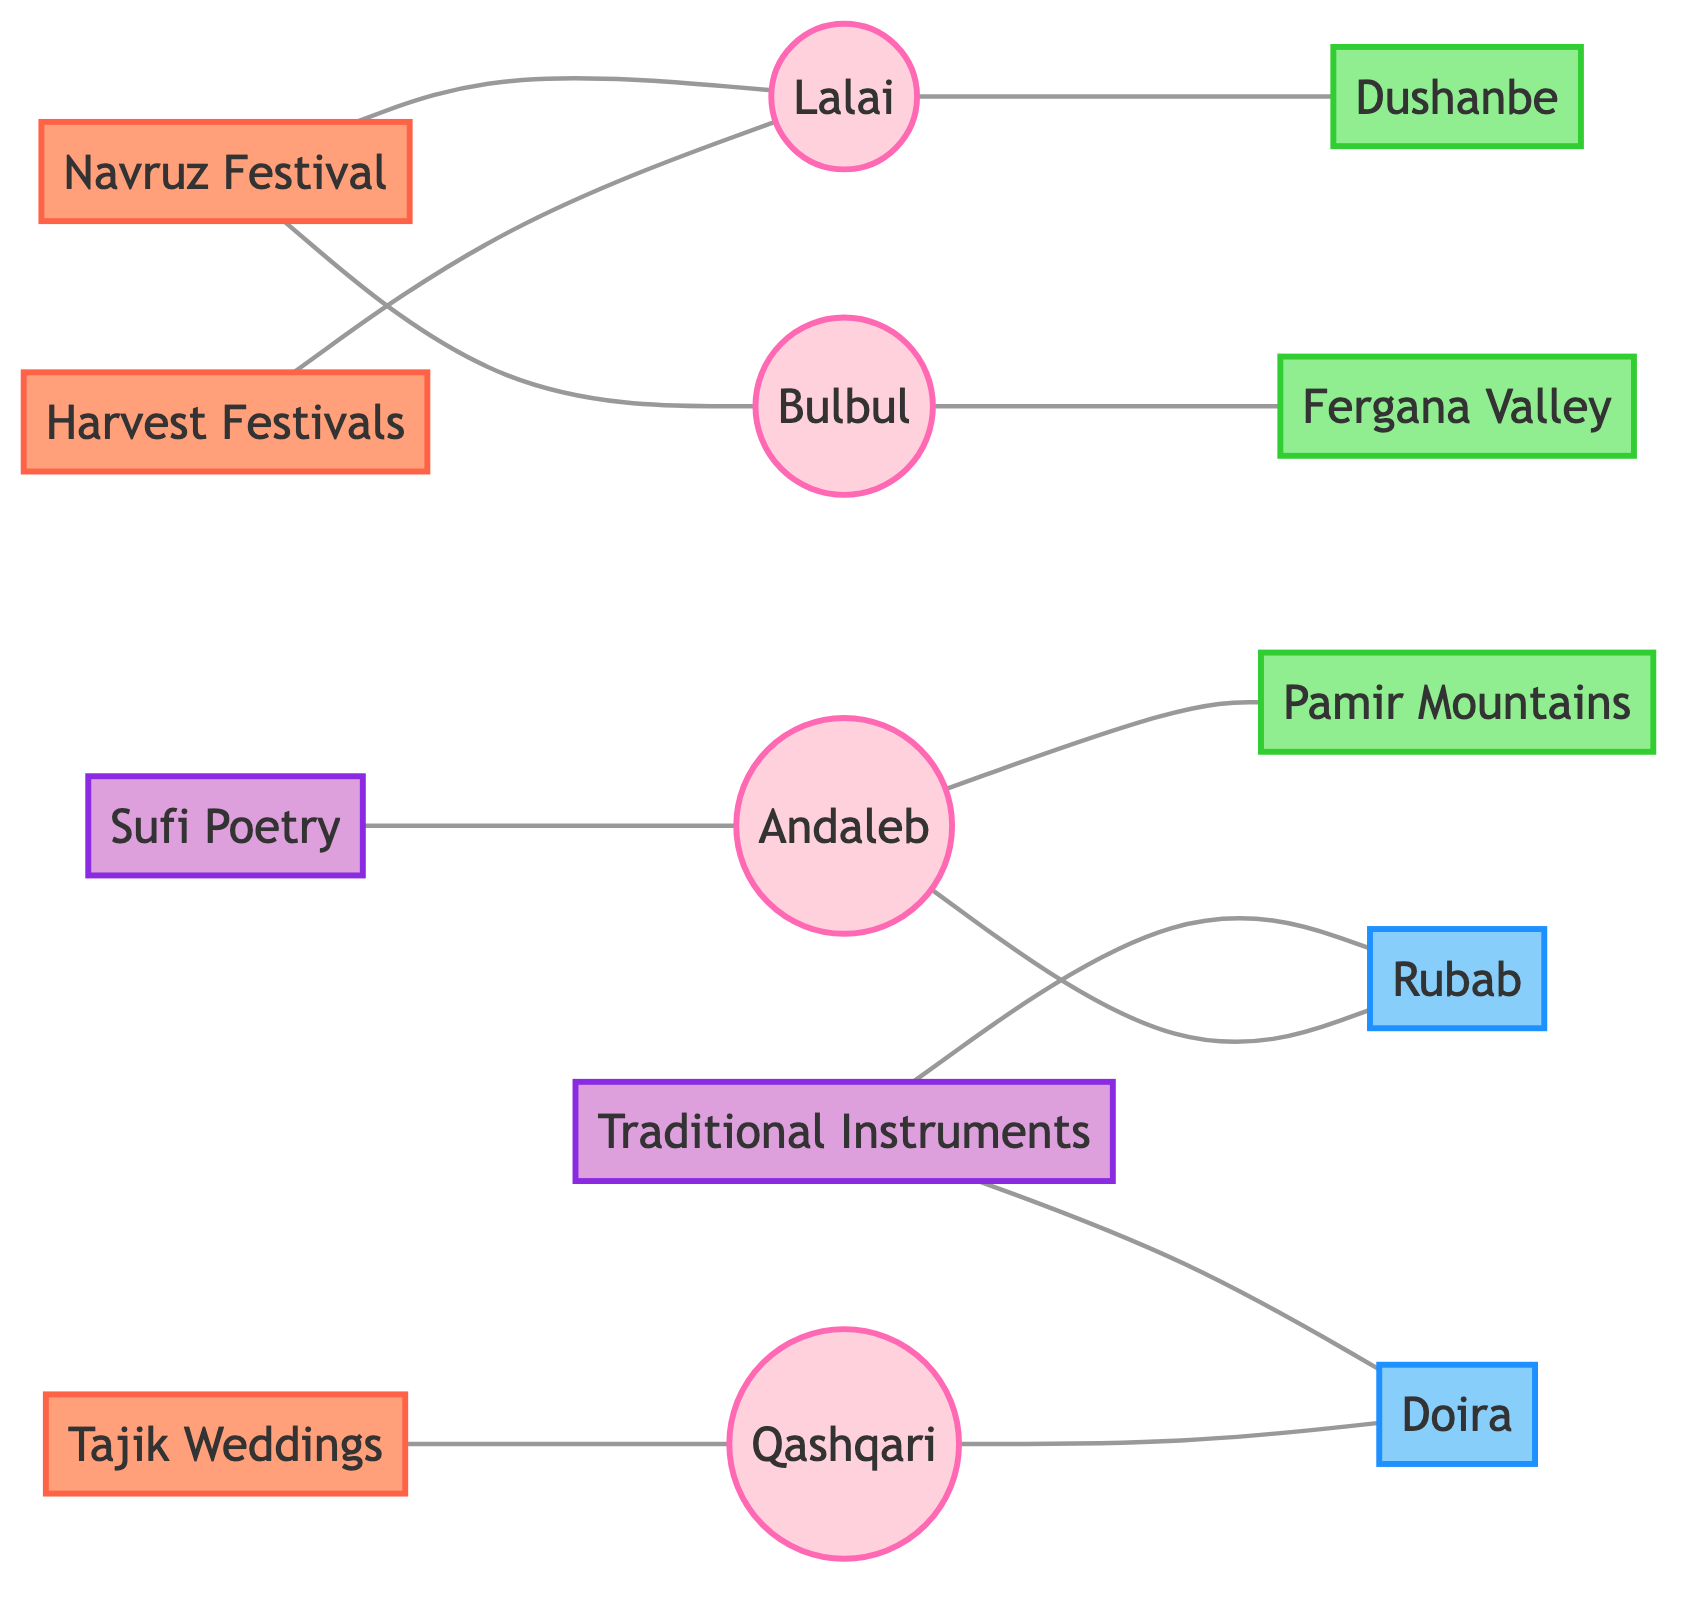What is the origin of the Andaleb folk song? The diagram shows a direct connection labeled "origin" between the Andaleb folk song and the Pamir Mountains. This indicates that the Pamir Mountains are the cultural origin of the Andaleb folk song.
Answer: Pamir Mountains Which folk song is associated with weddings? The diagram indicates a connection labeled "performedAt" between the Qashqari folk song and Tajik Weddings, thereby showing that the Qashqari folk song is associated with this event.
Answer: Qashqari How many songs are listed in the diagram? By counting the nodes that represent songs in the diagram, we find there are four song nodes: Andaleb, Bulbul, Lalai, and Qashqari. Thus, there are a total of four folk songs.
Answer: 4 What is performed during the Navruz festival? The diagram features two connections from Navruz, labeled "performedDuring," leading to the Lalai and Bulbul folk songs. This means both songs are associated with the Navruz festival.
Answer: Lalai and Bulbul Which traditional instrument accompanies the Andaleb folk song? The connection on the diagram between the Andaleb folk song and the Rubab instrument is labeled "accompaniedBy," indicating that the Rubab is the traditional instrument played with the Andaleb folk song.
Answer: Rubab What are the two traditional instruments included in the diagram? The diagram defines a node for Traditional Instruments with connections leading to two instruments: Rubab and Doira. This confirms that both these instruments are included as traditional.
Answer: Rubab and Doira 